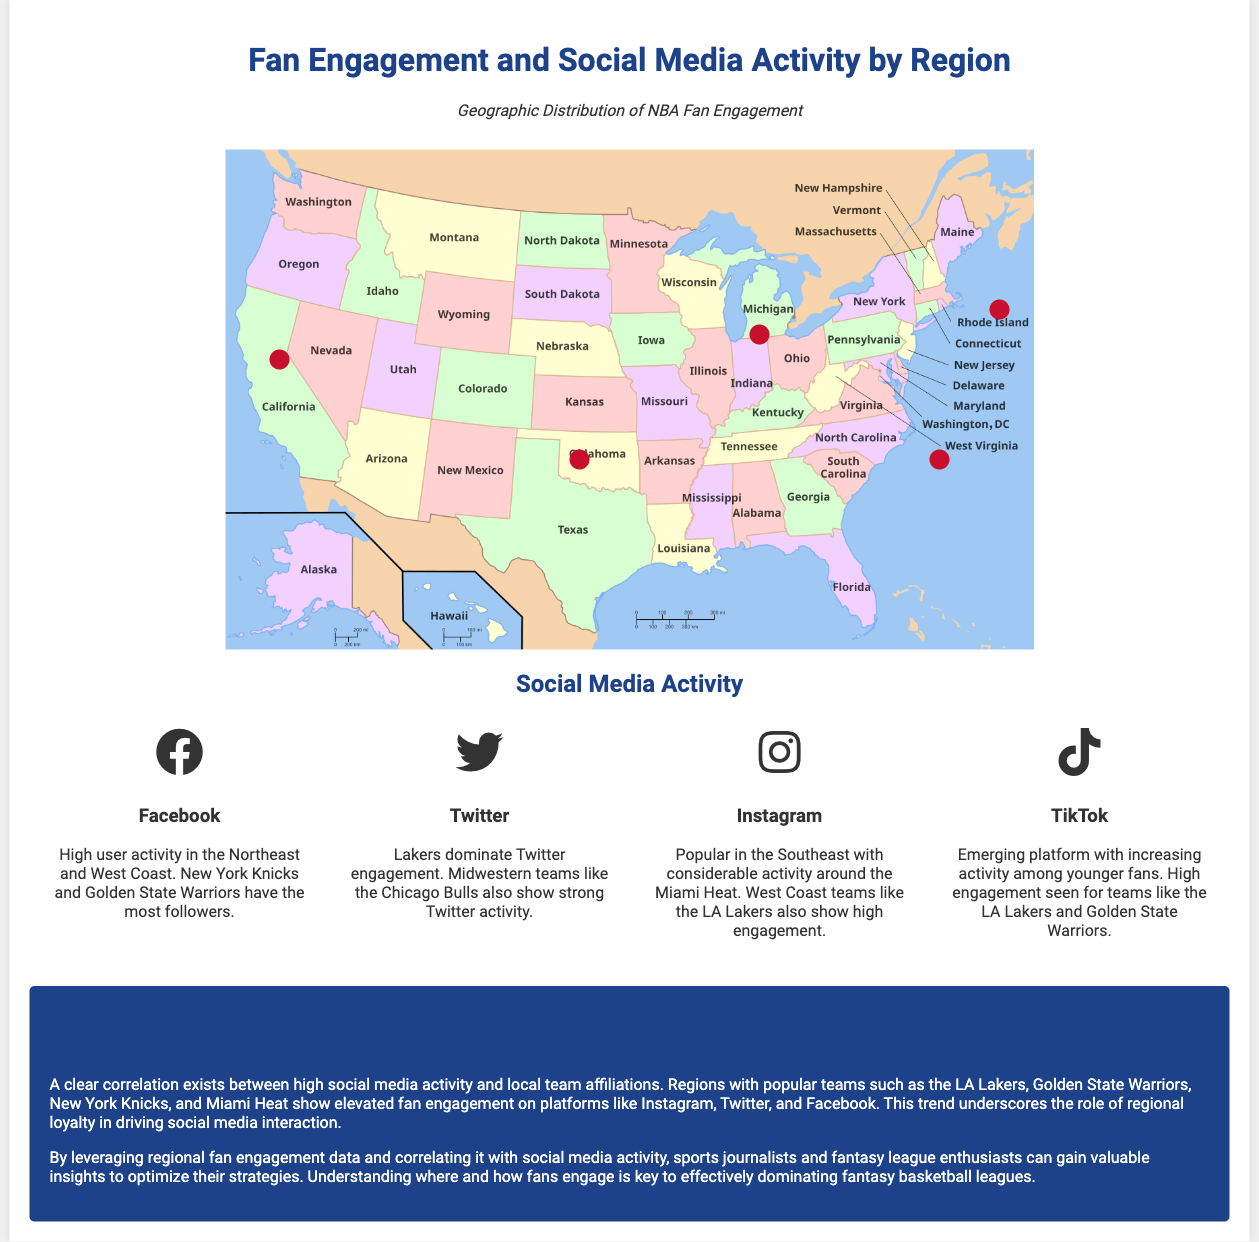What region shows high engagement driven by New York and Boston? The Northeast region is highlighted as having high engagement due to cities like New York and Boston.
Answer: Northeast Which NBA teams are mentioned for the West Coast in the infographic? The infographic notes that the Los Angeles Lakers and Golden State Warriors are the prominent teams on the West Coast.
Answer: Los Angeles Lakers, Golden State Warriors In which social media platform do the Lakers dominate engagement? The document explicitly states that the Lakers dominate Twitter engagement.
Answer: Twitter What key correlation is highlighted in the conclusion? The conclusion discusses a correlation between high social media activity and local team affiliations, mainly referring to popular teams.
Answer: Local team affiliations Which region has a robust social media presence due to the Miami Heat? The Southeast region is identified as having a robust social media presence tied to the Miami Heat.
Answer: Southeast What type of activity is increasing on TikTok? The infographic mentions that TikTok is seeing increasing activity among younger fans.
Answer: Activity among younger fans Which NBA team shows considerable activity on Instagram in the Southeast? The Miami Heat is noted for its considerable activity on Instagram in the Southeast.
Answer: Miami Heat What are the significant teams from the Southwest region? The infographic lists the Dallas Mavericks, Houston Rockets, and San Antonio Spurs as significant teams in the Southwest region.
Answer: Dallas Mavericks, Houston Rockets, San Antonio Spurs 